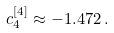<formula> <loc_0><loc_0><loc_500><loc_500>c _ { 4 } ^ { [ 4 ] } \approx - 1 . 4 7 2 \, .</formula> 